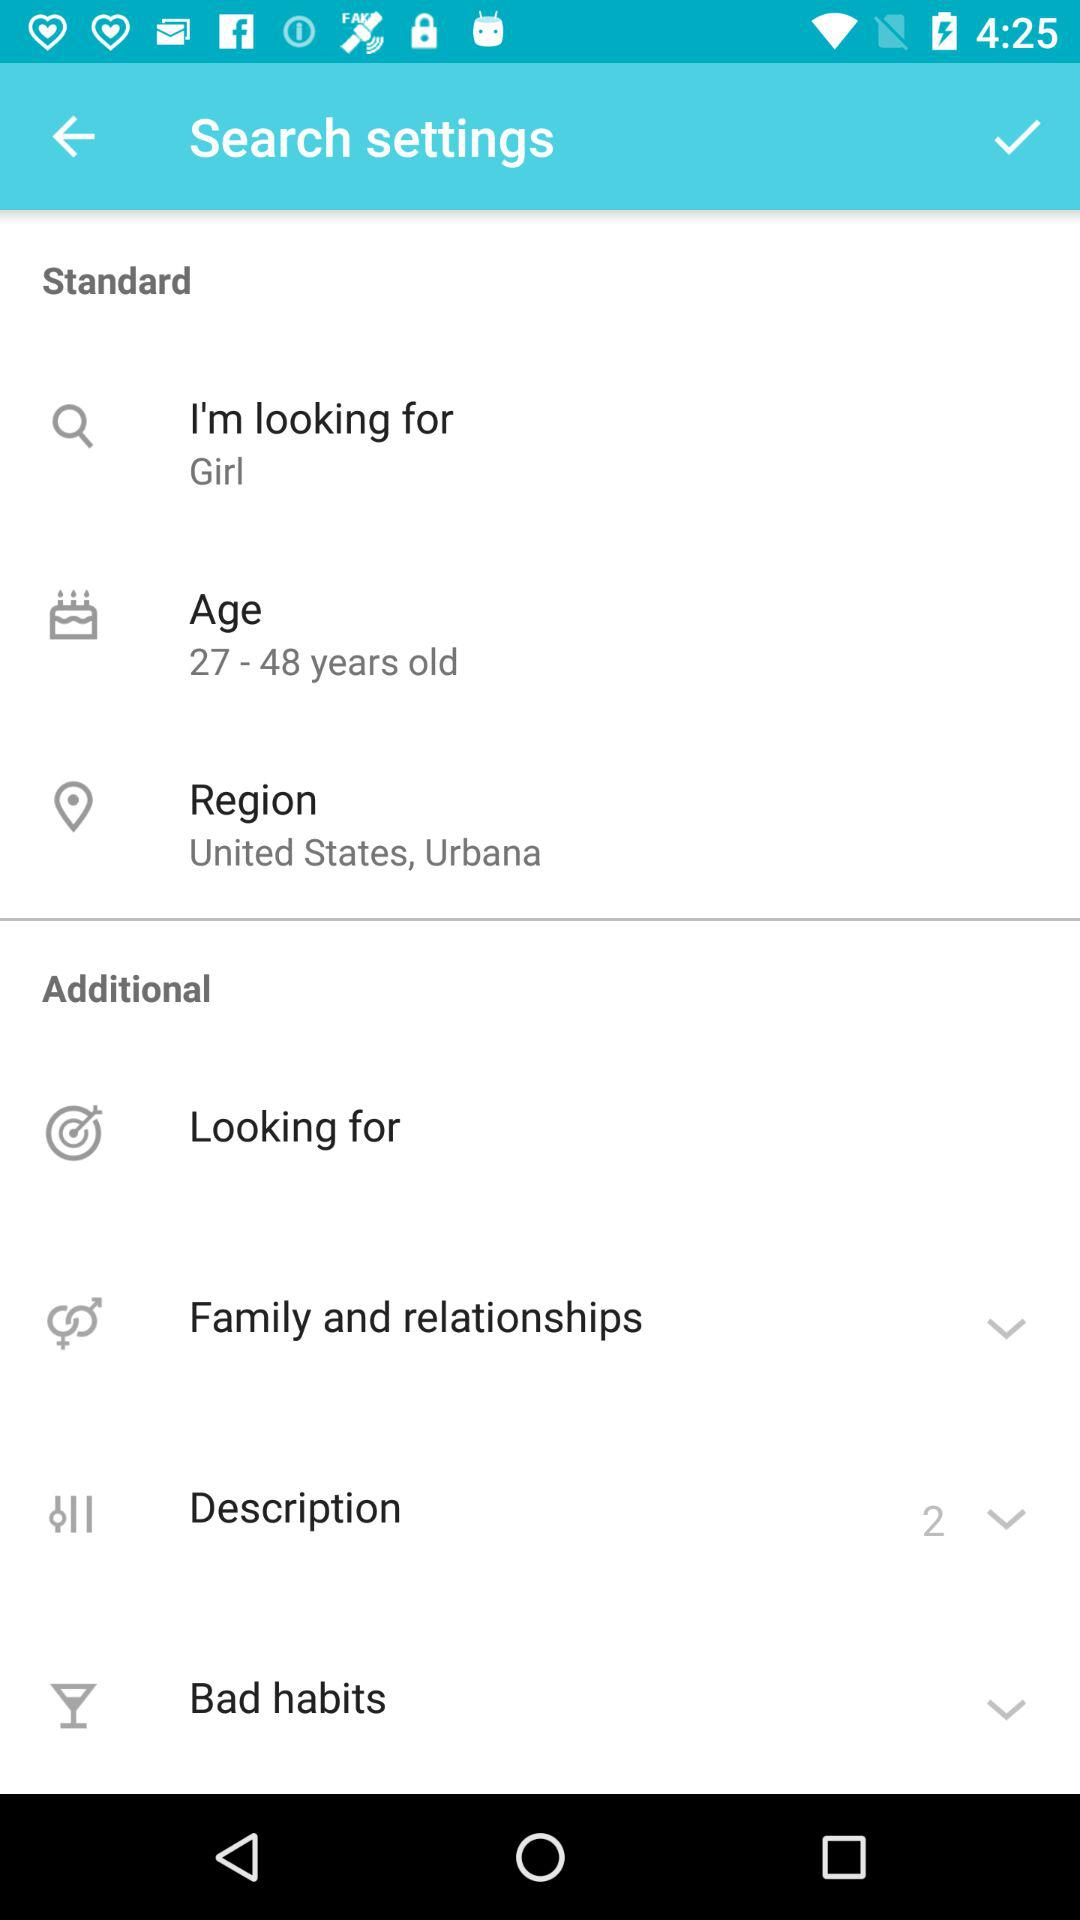What's the region? The region is the United States, Urbana. 